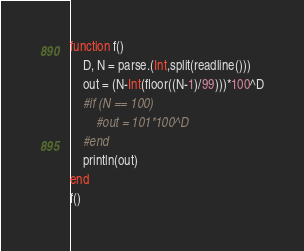<code> <loc_0><loc_0><loc_500><loc_500><_Julia_>function f()
    D, N = parse.(Int,split(readline()))
    out = (N-Int(floor((N-1)/99)))*100^D
    #if (N == 100) 
        #out = 101*100^D
    #end
    println(out)
end
f()</code> 